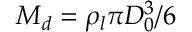Convert formula to latex. <formula><loc_0><loc_0><loc_500><loc_500>M _ { d } = \rho _ { l } \pi D _ { 0 } ^ { 3 } / 6</formula> 